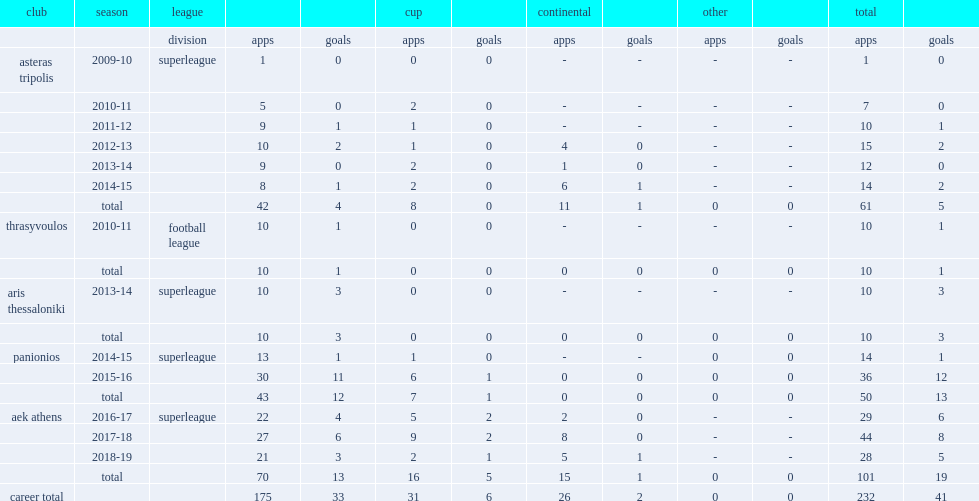Which club did anastasios play for in 2010-11? Asteras tripolis. 